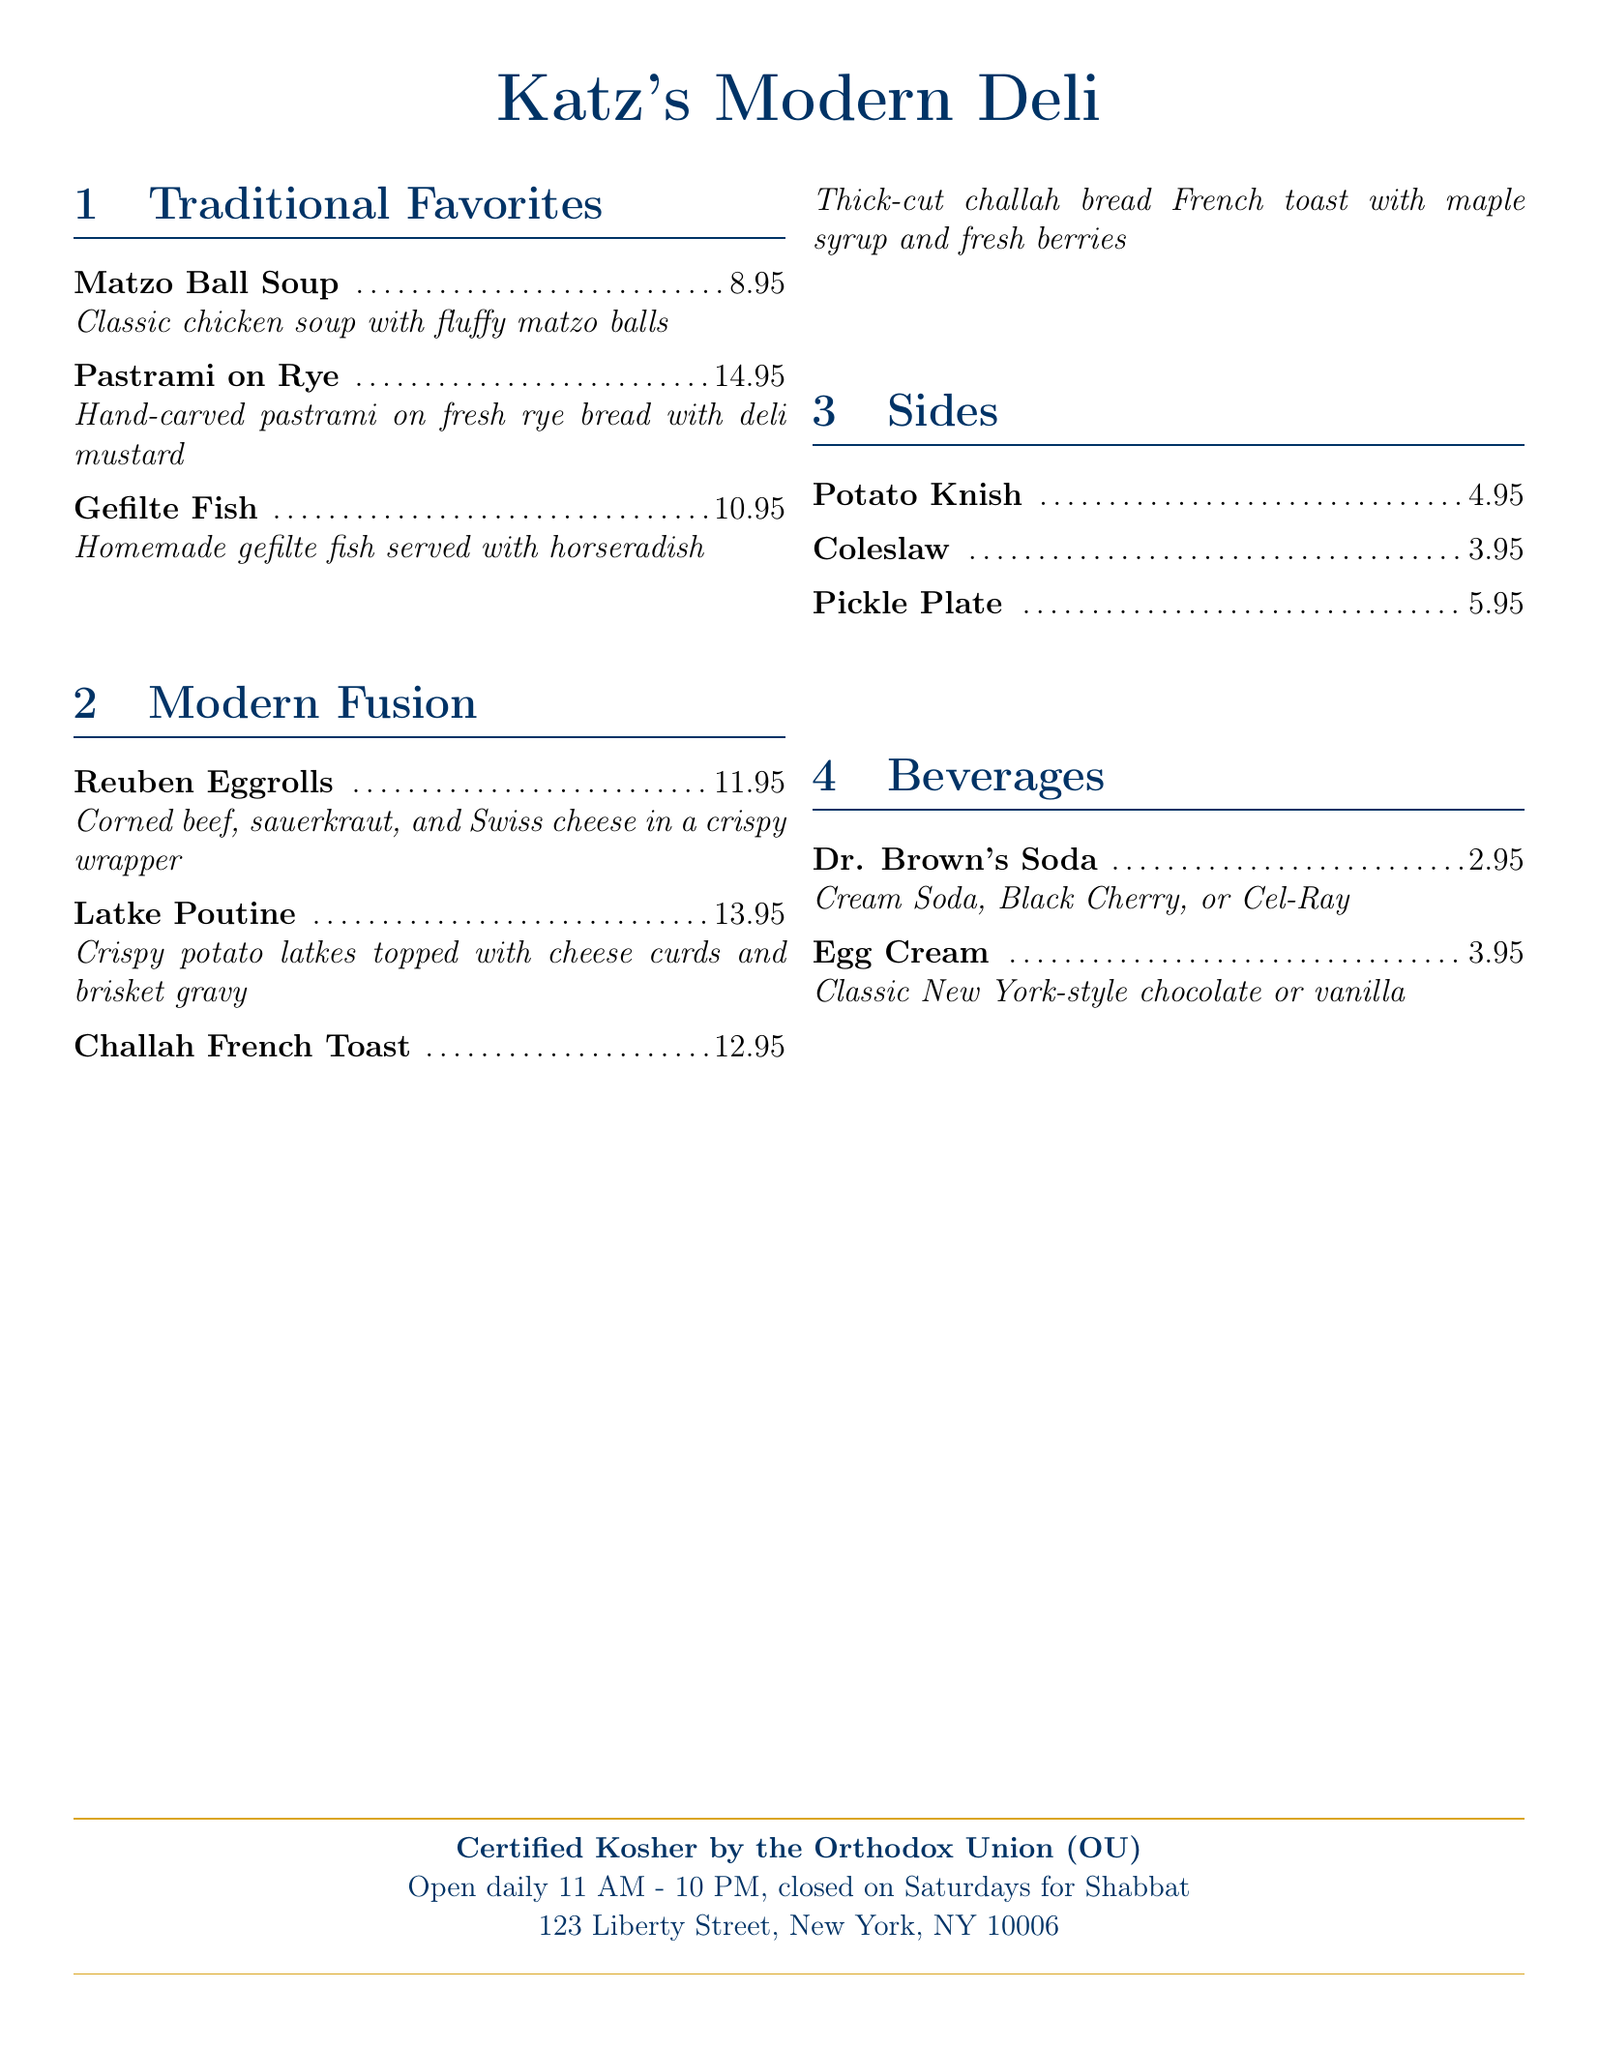What is the price of Matzo Ball Soup? The price of Matzo Ball Soup is listed in the "Traditional Favorites" section of the menu.
Answer: 8.95 What type of bread is used for the Pastrami on Rye? The Pastrami on Rye is made with fresh rye bread, as noted in the menu description.
Answer: Rye bread How much does a Potato Knish cost? The cost of Potato Knish is indicated in the "Sides" section of the menu.
Answer: 4.95 Which dish features a crispy wrapper? The "Reuben Eggrolls" are specifically noted to be in a crispy wrapper.
Answer: Reuben Eggrolls What beverage is listed for $2.95? The price of $2.95 corresponds to the beverages available on the menu.
Answer: Dr. Brown's Soda What are the hours of operation for the deli? The hours of operation are specified towards the bottom of the menu.
Answer: 11 AM - 10 PM Which dish includes cheese curds? The "Latke Poutine" is described as being topped with cheese curds.
Answer: Latke Poutine How is the gefilte fish served? The description of the gefilte fish indicates it is served with horseradish.
Answer: With horseradish 